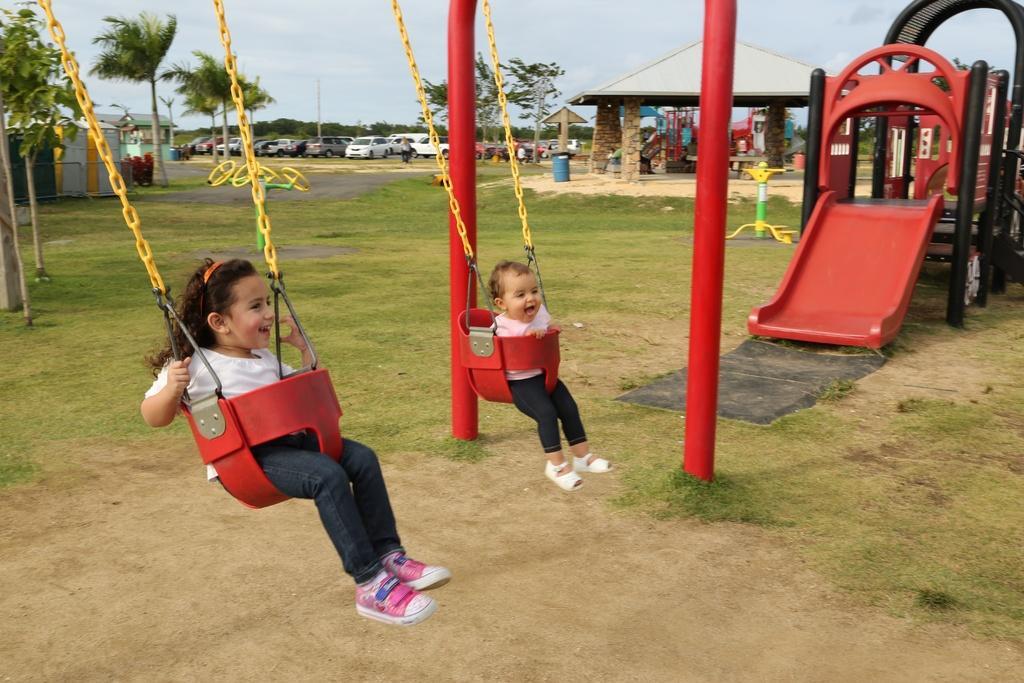Please provide a concise description of this image. This image is taken inside a park. Two kids are sitting on the swing. Here there is a slide. In the background there are buildings, shelter, dustbin, trees. Here many cars are parked. The sky is cloudy. 